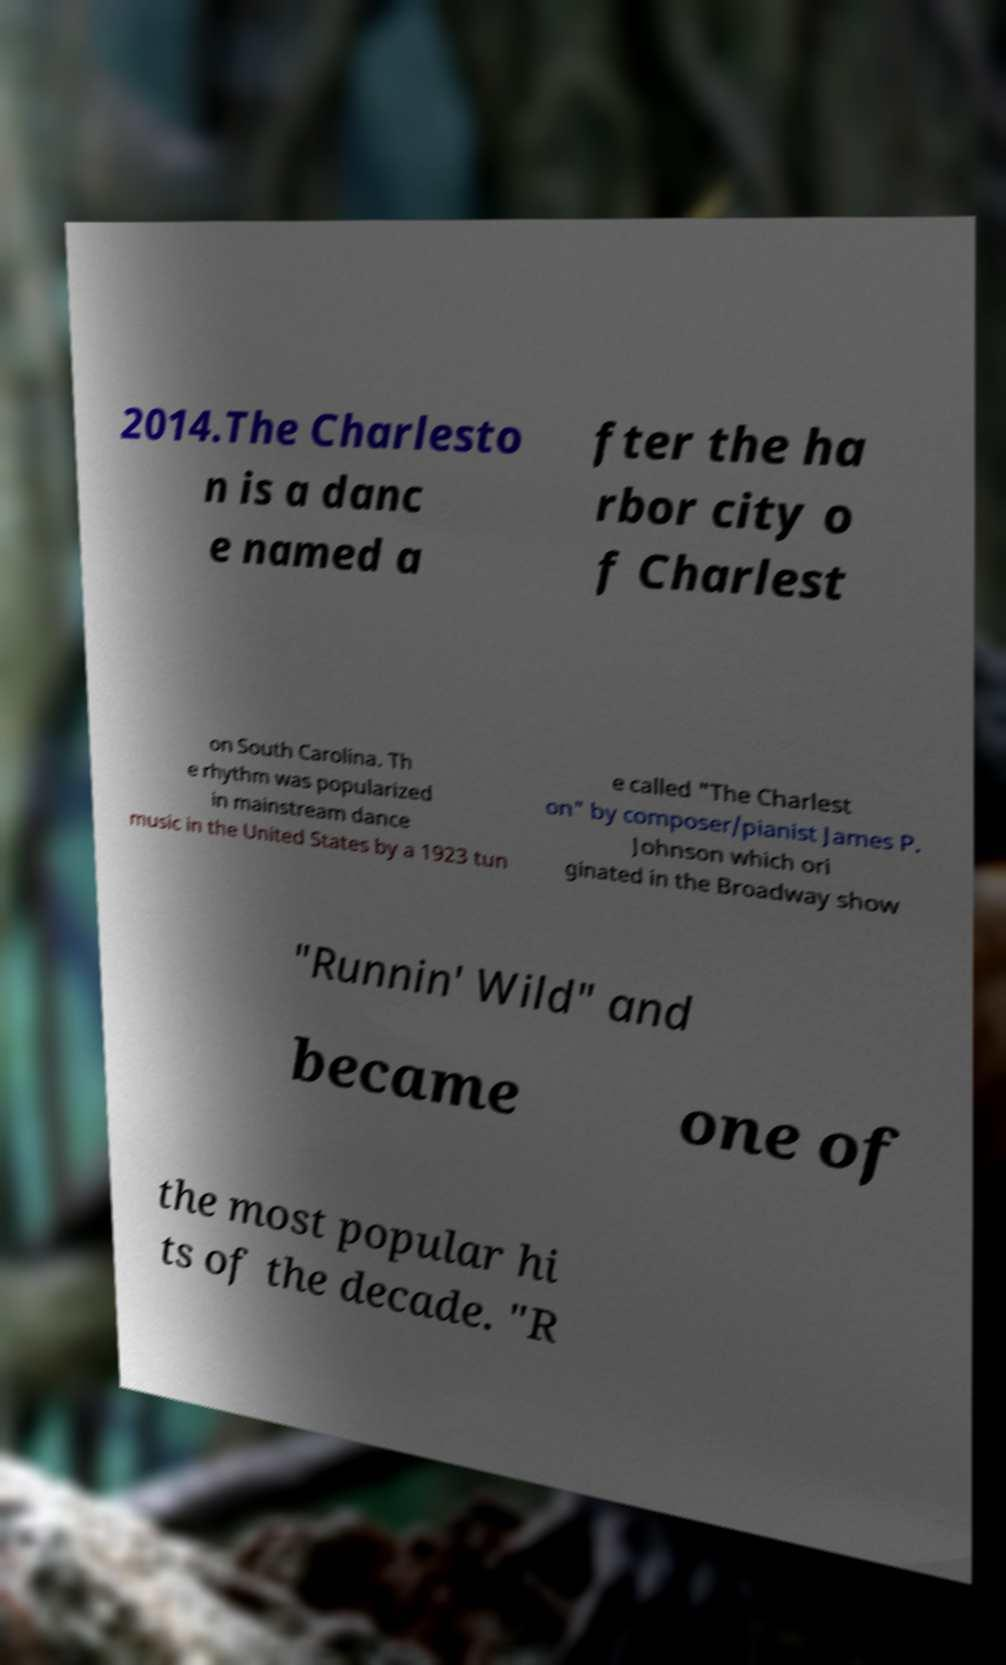Could you extract and type out the text from this image? 2014.The Charlesto n is a danc e named a fter the ha rbor city o f Charlest on South Carolina. Th e rhythm was popularized in mainstream dance music in the United States by a 1923 tun e called "The Charlest on" by composer/pianist James P. Johnson which ori ginated in the Broadway show "Runnin' Wild" and became one of the most popular hi ts of the decade. "R 